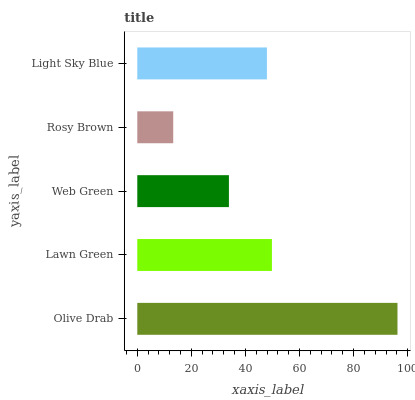Is Rosy Brown the minimum?
Answer yes or no. Yes. Is Olive Drab the maximum?
Answer yes or no. Yes. Is Lawn Green the minimum?
Answer yes or no. No. Is Lawn Green the maximum?
Answer yes or no. No. Is Olive Drab greater than Lawn Green?
Answer yes or no. Yes. Is Lawn Green less than Olive Drab?
Answer yes or no. Yes. Is Lawn Green greater than Olive Drab?
Answer yes or no. No. Is Olive Drab less than Lawn Green?
Answer yes or no. No. Is Light Sky Blue the high median?
Answer yes or no. Yes. Is Light Sky Blue the low median?
Answer yes or no. Yes. Is Olive Drab the high median?
Answer yes or no. No. Is Rosy Brown the low median?
Answer yes or no. No. 